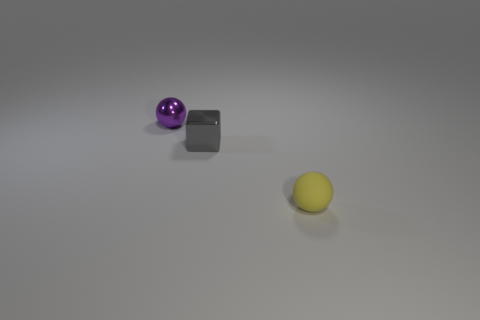Can you describe the lighting and shadows in the scene? The lighting in the scene comes from above, slightly favoring the left side, as evidenced by the shadows cast directly opposite the light source. Each object casts a soft-edged shadow, indicating that the light source is not extremely close. The light appears to be diffused, possibly by a softbox or similar photography tool, resulting in gentle, dispersed shadows with no harsh lines. 